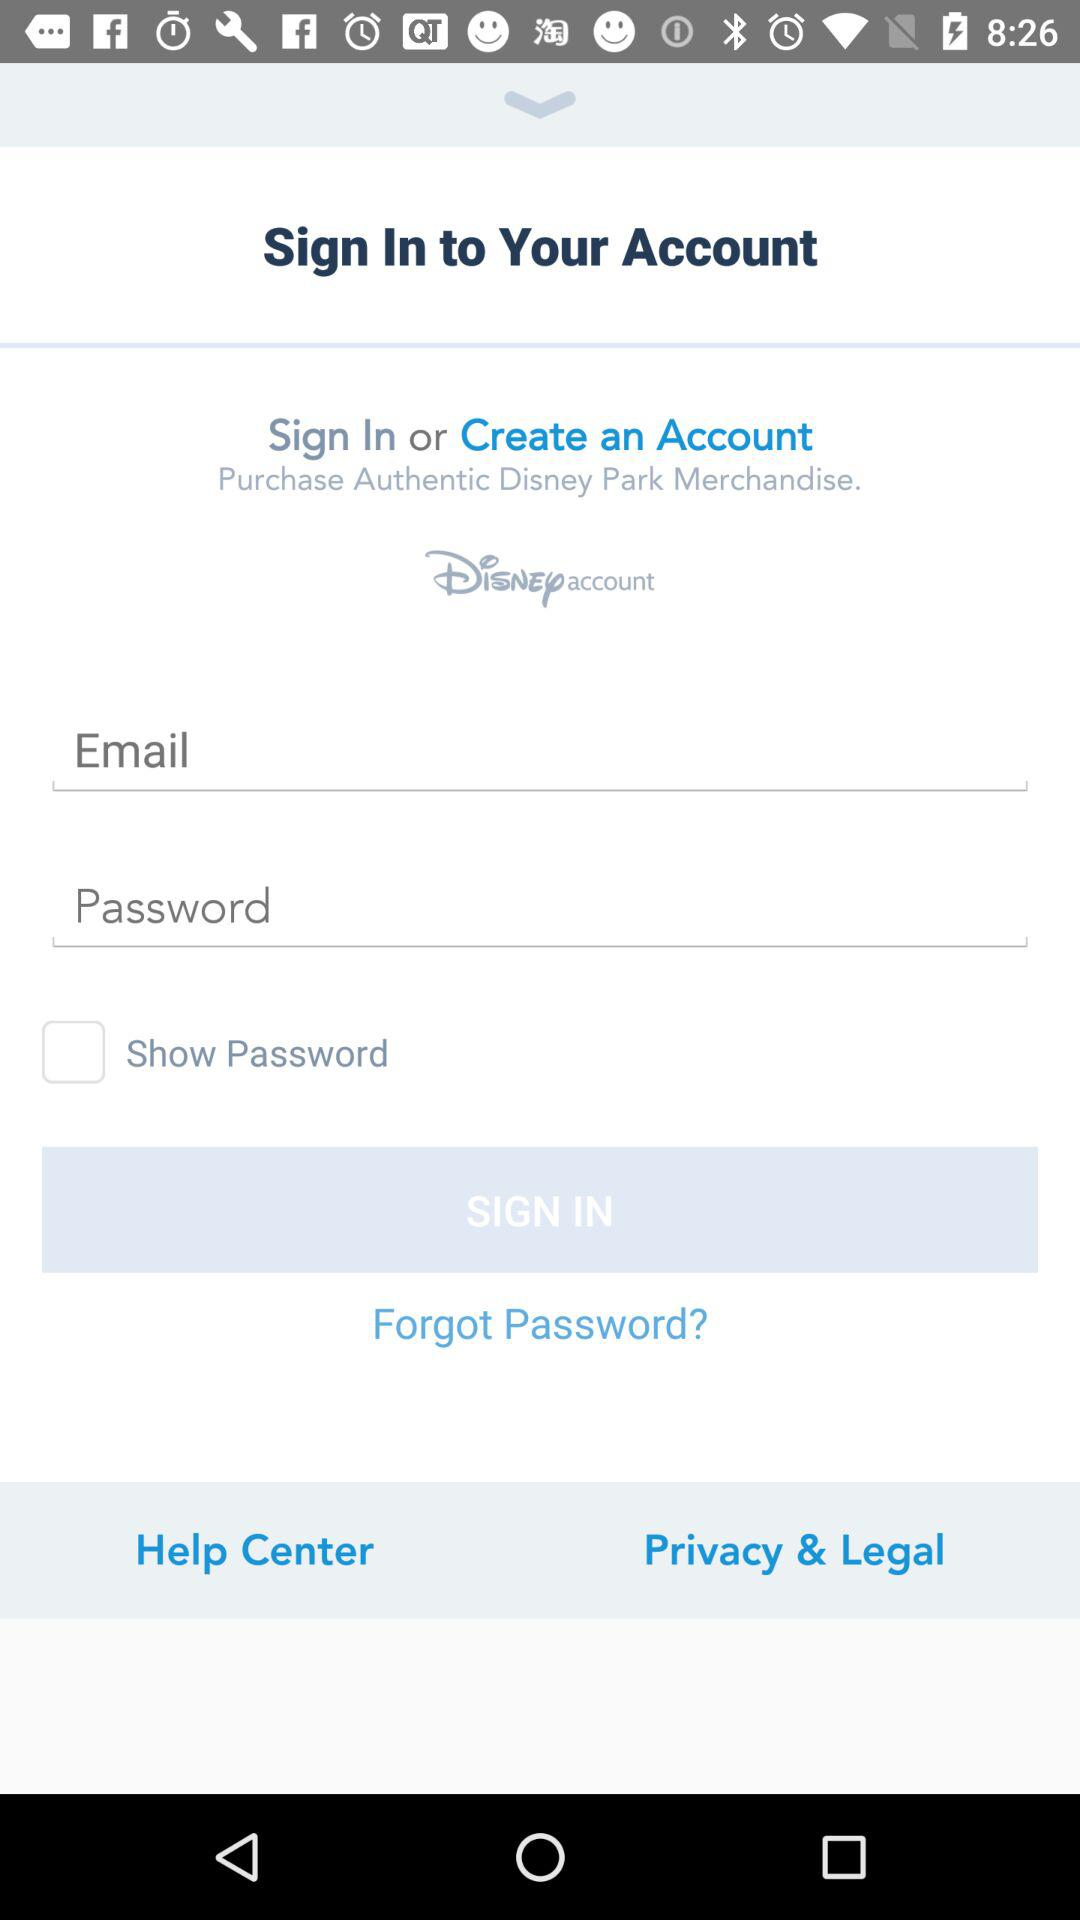How many fields are required to sign in?
Answer the question using a single word or phrase. 2 